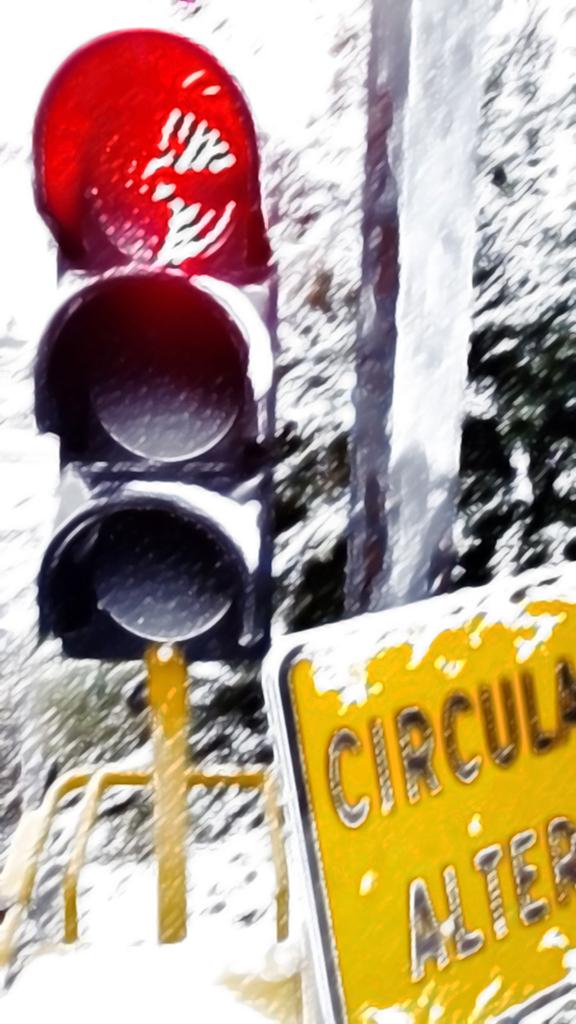What does the yellow sign say?
Your answer should be very brief. Circula alter. 